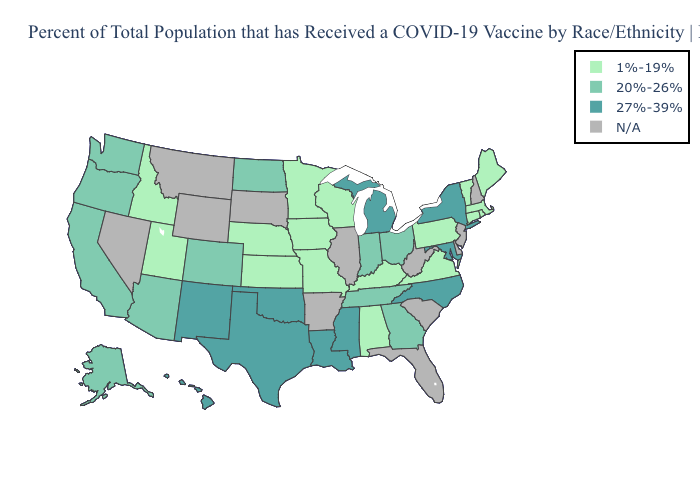How many symbols are there in the legend?
Quick response, please. 4. What is the highest value in the USA?
Quick response, please. 27%-39%. Name the states that have a value in the range 1%-19%?
Answer briefly. Alabama, Connecticut, Idaho, Iowa, Kansas, Kentucky, Maine, Massachusetts, Minnesota, Missouri, Nebraska, Pennsylvania, Rhode Island, Utah, Vermont, Virginia, Wisconsin. What is the highest value in the MidWest ?
Keep it brief. 27%-39%. What is the lowest value in the USA?
Short answer required. 1%-19%. Which states have the lowest value in the West?
Write a very short answer. Idaho, Utah. Does the first symbol in the legend represent the smallest category?
Quick response, please. Yes. What is the highest value in the MidWest ?
Be succinct. 27%-39%. Which states have the highest value in the USA?
Give a very brief answer. Hawaii, Louisiana, Maryland, Michigan, Mississippi, New Mexico, New York, North Carolina, Oklahoma, Texas. What is the highest value in the USA?
Answer briefly. 27%-39%. Which states have the highest value in the USA?
Write a very short answer. Hawaii, Louisiana, Maryland, Michigan, Mississippi, New Mexico, New York, North Carolina, Oklahoma, Texas. What is the highest value in the USA?
Answer briefly. 27%-39%. Does North Carolina have the highest value in the South?
Quick response, please. Yes. What is the value of Mississippi?
Keep it brief. 27%-39%. 